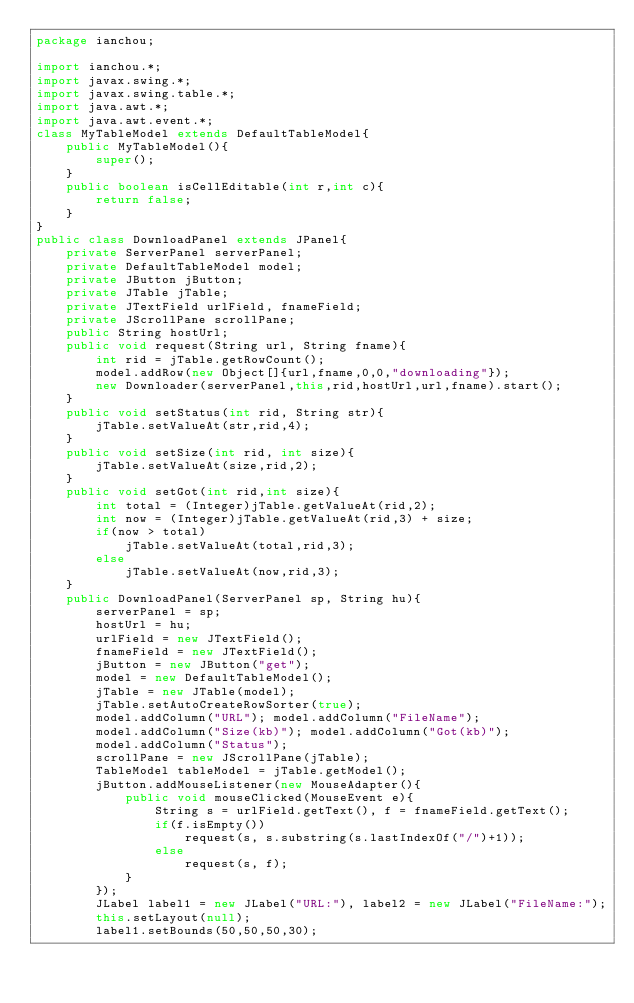Convert code to text. <code><loc_0><loc_0><loc_500><loc_500><_Java_>package ianchou;

import ianchou.*;
import javax.swing.*;
import javax.swing.table.*;
import java.awt.*;
import java.awt.event.*;
class MyTableModel extends DefaultTableModel{
	public MyTableModel(){
		super();
	}
	public boolean isCellEditable(int r,int c){
		return false;
	}	
}
public class DownloadPanel extends JPanel{
	private ServerPanel serverPanel;
	private DefaultTableModel model;
	private JButton jButton;
	private JTable jTable;
	private JTextField urlField, fnameField;
	private JScrollPane scrollPane;
	public String hostUrl;
	public void request(String url, String fname){
		int rid = jTable.getRowCount();
		model.addRow(new Object[]{url,fname,0,0,"downloading"});
		new Downloader(serverPanel,this,rid,hostUrl,url,fname).start();
	}
	public void setStatus(int rid, String str){
		jTable.setValueAt(str,rid,4);
	}
	public void setSize(int rid, int size){
		jTable.setValueAt(size,rid,2);
	}
	public void setGot(int rid,int size){
		int total = (Integer)jTable.getValueAt(rid,2);
		int now = (Integer)jTable.getValueAt(rid,3) + size;
		if(now > total)
			jTable.setValueAt(total,rid,3);
		else
			jTable.setValueAt(now,rid,3);
	}
	public DownloadPanel(ServerPanel sp, String hu){
		serverPanel = sp;
		hostUrl = hu;
		urlField = new JTextField();
		fnameField = new JTextField();
		jButton = new JButton("get");
		model = new DefaultTableModel();
		jTable = new JTable(model);
		jTable.setAutoCreateRowSorter(true);
		model.addColumn("URL"); model.addColumn("FileName"); 
		model.addColumn("Size(kb)"); model.addColumn("Got(kb)");
		model.addColumn("Status");
		scrollPane = new JScrollPane(jTable);
		TableModel tableModel = jTable.getModel();
		jButton.addMouseListener(new MouseAdapter(){
			public void mouseClicked(MouseEvent e){
				String s = urlField.getText(), f = fnameField.getText();
				if(f.isEmpty())
					request(s, s.substring(s.lastIndexOf("/")+1));
				else
					request(s, f);
			}
		});
		JLabel label1 = new JLabel("URL:"), label2 = new JLabel("FileName:");
		this.setLayout(null);
		label1.setBounds(50,50,50,30);</code> 